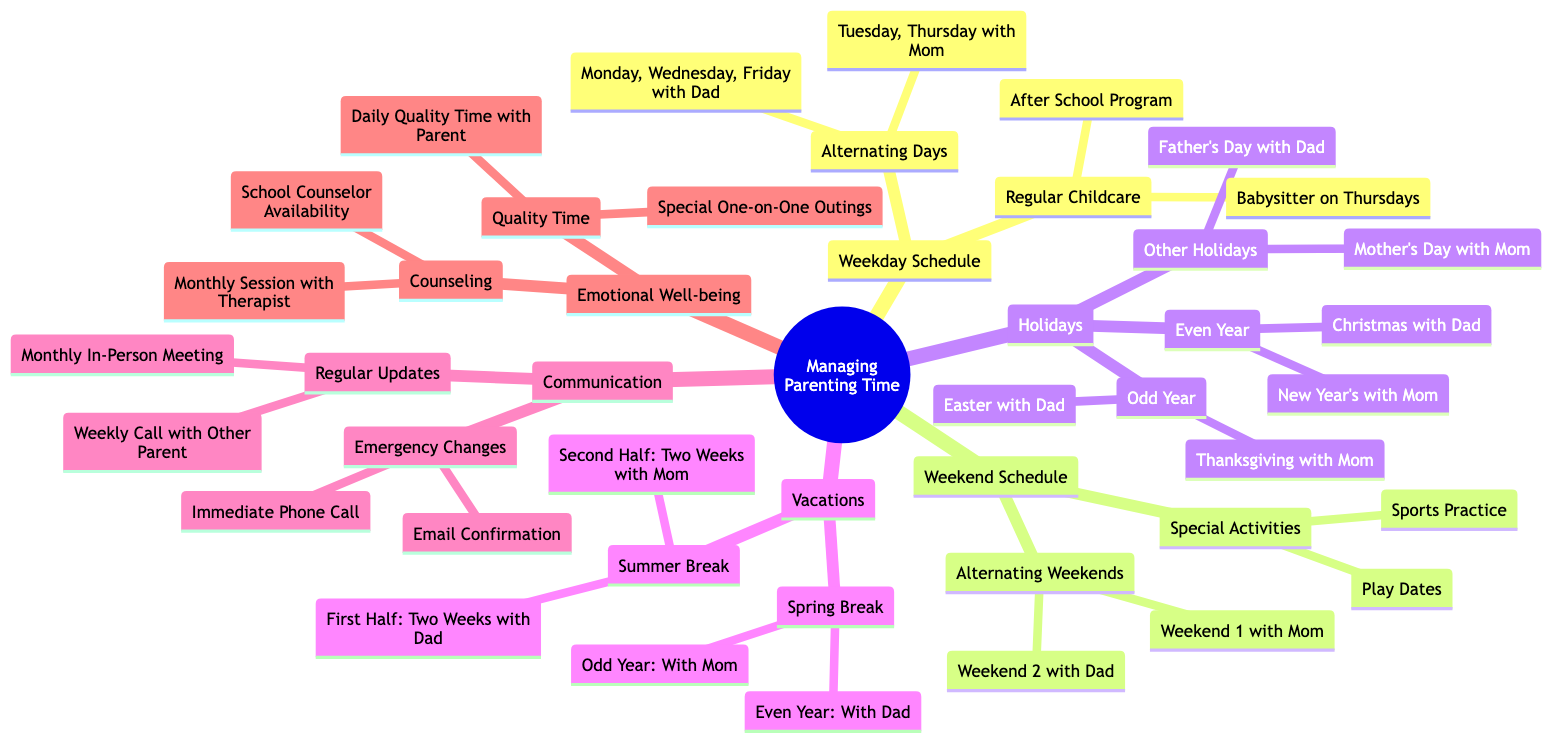What are the alternating days for the weekday schedule? The diagram specifies that the alternating days for the weekday schedule are Monday, Wednesday, Friday with Dad, Tuesday, and Thursday with Mom. This information can be found directly under the Weekday Schedule section.
Answer: Monday, Wednesday, Friday with Dad, Tuesday, Thursday with Mom How many special activities are listed for the weekend schedule? The weekend schedule indicates there are two special activities: Sports Practice and Play Dates. The count can be easily seen in the Special Activities section.
Answer: 2 When does the child spend Thanksgiving with Mom? According to the diagram, Thanksgiving is spent with Mom in odd years. This is clearly stated in the Holidays section under Odd Year.
Answer: Thanksgiving with Mom What are the two weeks for dad during summer break? The diagram states that during summer break, the first half consists of two weeks with Dad. The specific breakdown can be found in the Vacations section under Summer Break.
Answer: Two Weeks with Dad What method is used for regular updates? The regular updates mentioned in the Communication section include a weekly call with the other parent and a monthly in-person meeting. This clearly indicates both methods used for communication.
Answer: Weekly Call with Other Parent, Monthly In-Person Meeting Which parent does the child spend Christmas with in an even year? In the diagram, it is shown that during even years, the child spends Christmas with Dad. This information can be found in the Holidays section under Even Year.
Answer: Christmas with Dad How often does the child have counseling sessions? The Emotional Well-being section indicates that the child has monthly sessions with a therapist. This information is directly stated under Counseling.
Answer: Monthly Session with Therapist What is the emergency change protocol? The emergency change protocol specifies that an immediate phone call is required, followed by an email confirmation. This process can be found in the Communication section under Emergency Changes.
Answer: Immediate Phone Call, Email Confirmation Which week does the child spend spring break with Dad? The diagram states that during even years, the child spends spring break with Dad. This specific detail can be located in the Vacations section under Spring Break.
Answer: With Dad 